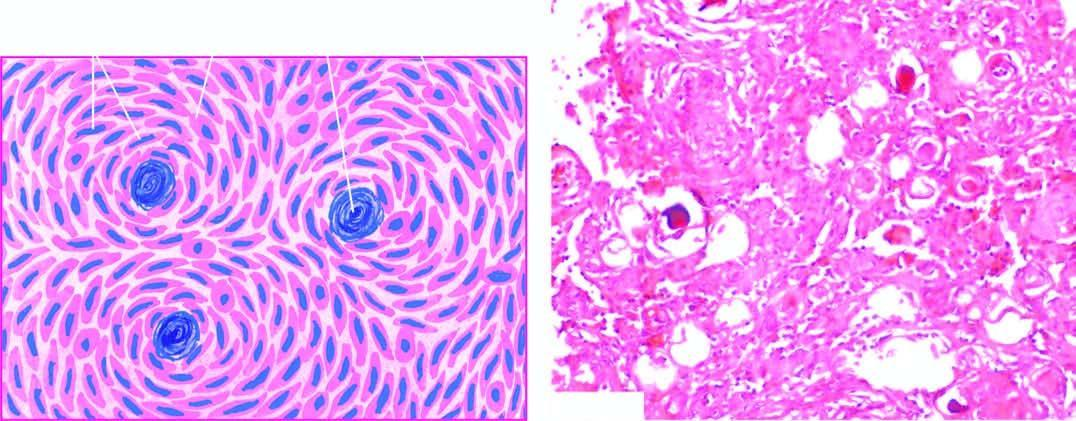what contain psammoma bodies?
Answer the question using a single word or phrase. Some of the whorls 